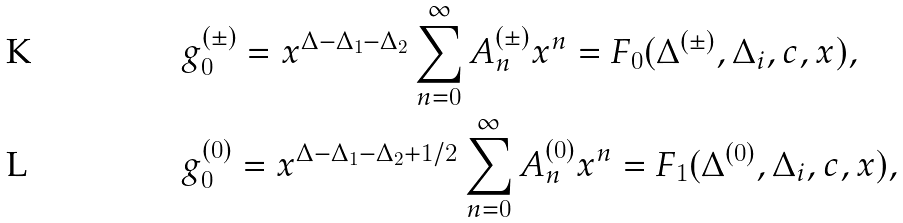Convert formula to latex. <formula><loc_0><loc_0><loc_500><loc_500>& g _ { 0 } ^ { ( \pm ) } = x ^ { \Delta - \Delta _ { 1 } - \Delta _ { 2 } } \sum _ { n = 0 } ^ { \infty } A _ { n } ^ { ( \pm ) } x ^ { n } = F _ { 0 } ( \Delta ^ { ( \pm ) } , \Delta _ { i } , c , x ) , \\ & g _ { 0 } ^ { ( 0 ) } = x ^ { \Delta - \Delta _ { 1 } - \Delta _ { 2 } + 1 / 2 } \sum _ { n = 0 } ^ { \infty } A _ { n } ^ { ( 0 ) } x ^ { n } = F _ { 1 } ( \Delta ^ { ( 0 ) } , \Delta _ { i } , c , x ) ,</formula> 